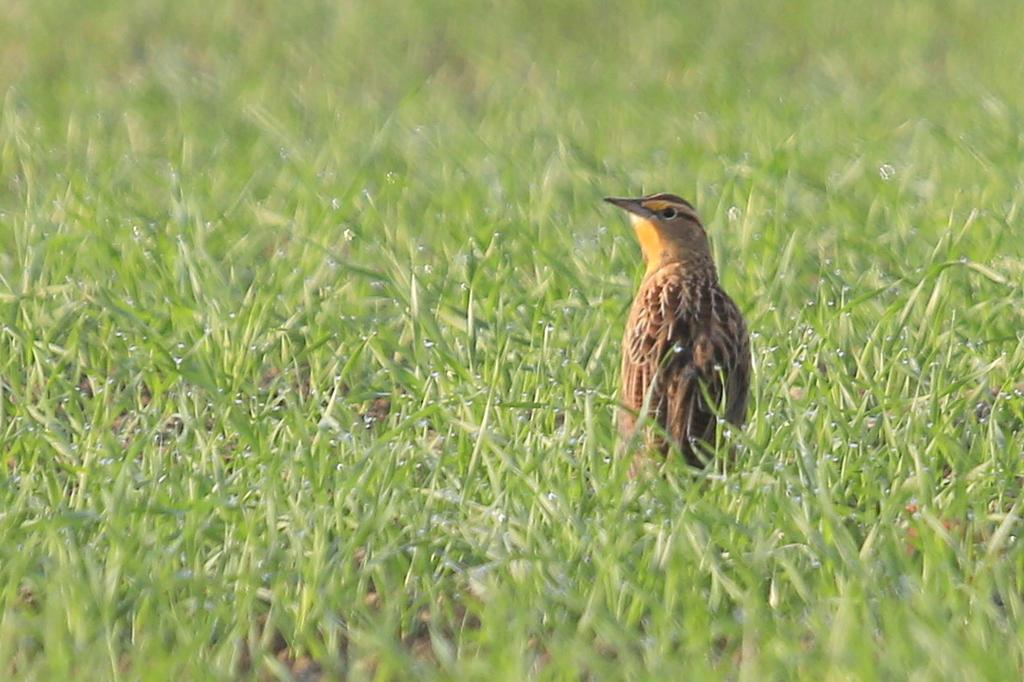What type of vegetation is present in the picture? There is grass in the picture. What animal can be seen on the grass? A bird is standing on the grass. What is the color of the bird? The bird is brown in color. Are there any patterns or designs on the bird? Yes, the bird has designs on it. What color is the bird's face? The bird's face is yellow in color. Is the bird wearing a scarf in the image? No, the bird is not wearing a scarf in the image. Can you see any adjustments being made to the grass in the image? No, there are no adjustments being made to the grass in the image. 